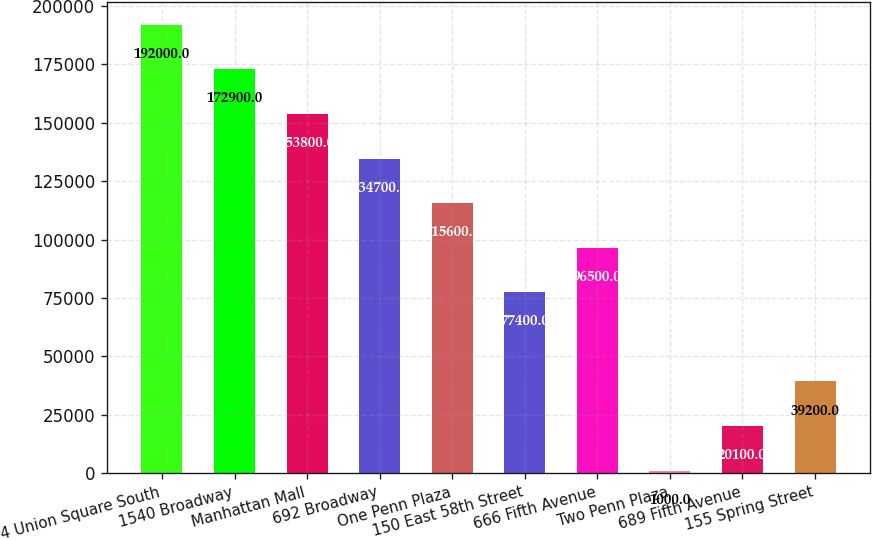<chart> <loc_0><loc_0><loc_500><loc_500><bar_chart><fcel>4 Union Square South<fcel>1540 Broadway<fcel>Manhattan Mall<fcel>692 Broadway<fcel>One Penn Plaza<fcel>150 East 58th Street<fcel>666 Fifth Avenue<fcel>Two Penn Plaza<fcel>689 Fifth Avenue<fcel>155 Spring Street<nl><fcel>192000<fcel>172900<fcel>153800<fcel>134700<fcel>115600<fcel>77400<fcel>96500<fcel>1000<fcel>20100<fcel>39200<nl></chart> 